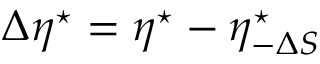<formula> <loc_0><loc_0><loc_500><loc_500>\Delta \eta ^ { ^ { * } } = \eta ^ { ^ { * } } - \eta _ { - \Delta S } ^ { ^ { * } }</formula> 